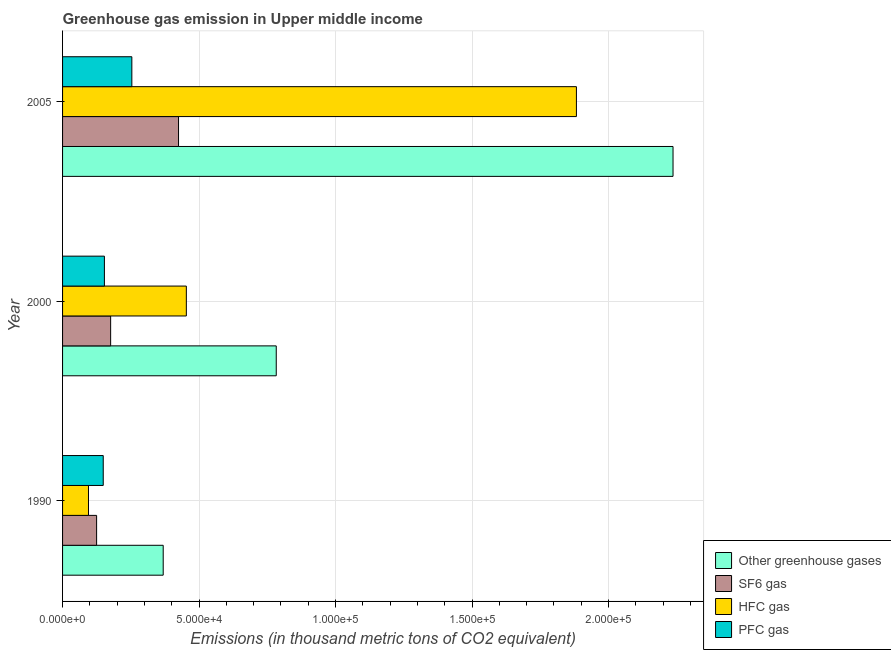How many groups of bars are there?
Provide a succinct answer. 3. Are the number of bars on each tick of the Y-axis equal?
Offer a terse response. Yes. In how many cases, is the number of bars for a given year not equal to the number of legend labels?
Keep it short and to the point. 0. What is the emission of pfc gas in 1990?
Keep it short and to the point. 1.49e+04. Across all years, what is the maximum emission of hfc gas?
Your answer should be compact. 1.88e+05. Across all years, what is the minimum emission of greenhouse gases?
Offer a very short reply. 3.69e+04. In which year was the emission of sf6 gas maximum?
Provide a succinct answer. 2005. In which year was the emission of sf6 gas minimum?
Keep it short and to the point. 1990. What is the total emission of hfc gas in the graph?
Ensure brevity in your answer.  2.43e+05. What is the difference between the emission of hfc gas in 2000 and that in 2005?
Offer a terse response. -1.43e+05. What is the difference between the emission of greenhouse gases in 1990 and the emission of pfc gas in 2005?
Your answer should be compact. 1.15e+04. What is the average emission of greenhouse gases per year?
Give a very brief answer. 1.13e+05. In the year 2000, what is the difference between the emission of pfc gas and emission of sf6 gas?
Give a very brief answer. -2284.5. In how many years, is the emission of hfc gas greater than 140000 thousand metric tons?
Ensure brevity in your answer.  1. What is the ratio of the emission of sf6 gas in 1990 to that in 2005?
Ensure brevity in your answer.  0.29. Is the emission of pfc gas in 1990 less than that in 2000?
Offer a very short reply. Yes. Is the difference between the emission of sf6 gas in 1990 and 2005 greater than the difference between the emission of greenhouse gases in 1990 and 2005?
Offer a terse response. Yes. What is the difference between the highest and the second highest emission of greenhouse gases?
Your response must be concise. 1.45e+05. What is the difference between the highest and the lowest emission of hfc gas?
Make the answer very short. 1.79e+05. Is the sum of the emission of pfc gas in 1990 and 2000 greater than the maximum emission of hfc gas across all years?
Offer a very short reply. No. What does the 4th bar from the top in 2005 represents?
Make the answer very short. Other greenhouse gases. What does the 2nd bar from the bottom in 1990 represents?
Your response must be concise. SF6 gas. Is it the case that in every year, the sum of the emission of greenhouse gases and emission of sf6 gas is greater than the emission of hfc gas?
Provide a short and direct response. Yes. Are all the bars in the graph horizontal?
Ensure brevity in your answer.  Yes. How many years are there in the graph?
Your response must be concise. 3. Are the values on the major ticks of X-axis written in scientific E-notation?
Your answer should be compact. Yes. Does the graph contain grids?
Your answer should be very brief. Yes. How many legend labels are there?
Give a very brief answer. 4. How are the legend labels stacked?
Ensure brevity in your answer.  Vertical. What is the title of the graph?
Your answer should be compact. Greenhouse gas emission in Upper middle income. Does "Argument" appear as one of the legend labels in the graph?
Provide a short and direct response. No. What is the label or title of the X-axis?
Keep it short and to the point. Emissions (in thousand metric tons of CO2 equivalent). What is the Emissions (in thousand metric tons of CO2 equivalent) in Other greenhouse gases in 1990?
Make the answer very short. 3.69e+04. What is the Emissions (in thousand metric tons of CO2 equivalent) in SF6 gas in 1990?
Your response must be concise. 1.25e+04. What is the Emissions (in thousand metric tons of CO2 equivalent) in HFC gas in 1990?
Your answer should be compact. 9496.9. What is the Emissions (in thousand metric tons of CO2 equivalent) of PFC gas in 1990?
Make the answer very short. 1.49e+04. What is the Emissions (in thousand metric tons of CO2 equivalent) in Other greenhouse gases in 2000?
Provide a short and direct response. 7.83e+04. What is the Emissions (in thousand metric tons of CO2 equivalent) in SF6 gas in 2000?
Your answer should be compact. 1.76e+04. What is the Emissions (in thousand metric tons of CO2 equivalent) in HFC gas in 2000?
Keep it short and to the point. 4.53e+04. What is the Emissions (in thousand metric tons of CO2 equivalent) of PFC gas in 2000?
Your answer should be very brief. 1.53e+04. What is the Emissions (in thousand metric tons of CO2 equivalent) in Other greenhouse gases in 2005?
Keep it short and to the point. 2.24e+05. What is the Emissions (in thousand metric tons of CO2 equivalent) in SF6 gas in 2005?
Make the answer very short. 4.25e+04. What is the Emissions (in thousand metric tons of CO2 equivalent) of HFC gas in 2005?
Give a very brief answer. 1.88e+05. What is the Emissions (in thousand metric tons of CO2 equivalent) in PFC gas in 2005?
Give a very brief answer. 2.54e+04. Across all years, what is the maximum Emissions (in thousand metric tons of CO2 equivalent) in Other greenhouse gases?
Provide a short and direct response. 2.24e+05. Across all years, what is the maximum Emissions (in thousand metric tons of CO2 equivalent) in SF6 gas?
Give a very brief answer. 4.25e+04. Across all years, what is the maximum Emissions (in thousand metric tons of CO2 equivalent) of HFC gas?
Give a very brief answer. 1.88e+05. Across all years, what is the maximum Emissions (in thousand metric tons of CO2 equivalent) of PFC gas?
Ensure brevity in your answer.  2.54e+04. Across all years, what is the minimum Emissions (in thousand metric tons of CO2 equivalent) of Other greenhouse gases?
Ensure brevity in your answer.  3.69e+04. Across all years, what is the minimum Emissions (in thousand metric tons of CO2 equivalent) in SF6 gas?
Keep it short and to the point. 1.25e+04. Across all years, what is the minimum Emissions (in thousand metric tons of CO2 equivalent) in HFC gas?
Offer a very short reply. 9496.9. Across all years, what is the minimum Emissions (in thousand metric tons of CO2 equivalent) in PFC gas?
Provide a short and direct response. 1.49e+04. What is the total Emissions (in thousand metric tons of CO2 equivalent) in Other greenhouse gases in the graph?
Provide a short and direct response. 3.39e+05. What is the total Emissions (in thousand metric tons of CO2 equivalent) of SF6 gas in the graph?
Provide a short and direct response. 7.26e+04. What is the total Emissions (in thousand metric tons of CO2 equivalent) of HFC gas in the graph?
Give a very brief answer. 2.43e+05. What is the total Emissions (in thousand metric tons of CO2 equivalent) in PFC gas in the graph?
Offer a very short reply. 5.56e+04. What is the difference between the Emissions (in thousand metric tons of CO2 equivalent) in Other greenhouse gases in 1990 and that in 2000?
Your answer should be very brief. -4.14e+04. What is the difference between the Emissions (in thousand metric tons of CO2 equivalent) in SF6 gas in 1990 and that in 2000?
Ensure brevity in your answer.  -5140.8. What is the difference between the Emissions (in thousand metric tons of CO2 equivalent) of HFC gas in 1990 and that in 2000?
Keep it short and to the point. -3.58e+04. What is the difference between the Emissions (in thousand metric tons of CO2 equivalent) in PFC gas in 1990 and that in 2000?
Offer a very short reply. -426.2. What is the difference between the Emissions (in thousand metric tons of CO2 equivalent) of Other greenhouse gases in 1990 and that in 2005?
Give a very brief answer. -1.87e+05. What is the difference between the Emissions (in thousand metric tons of CO2 equivalent) in SF6 gas in 1990 and that in 2005?
Make the answer very short. -3.00e+04. What is the difference between the Emissions (in thousand metric tons of CO2 equivalent) of HFC gas in 1990 and that in 2005?
Provide a succinct answer. -1.79e+05. What is the difference between the Emissions (in thousand metric tons of CO2 equivalent) in PFC gas in 1990 and that in 2005?
Provide a short and direct response. -1.05e+04. What is the difference between the Emissions (in thousand metric tons of CO2 equivalent) of Other greenhouse gases in 2000 and that in 2005?
Offer a very short reply. -1.45e+05. What is the difference between the Emissions (in thousand metric tons of CO2 equivalent) in SF6 gas in 2000 and that in 2005?
Provide a succinct answer. -2.49e+04. What is the difference between the Emissions (in thousand metric tons of CO2 equivalent) of HFC gas in 2000 and that in 2005?
Your answer should be very brief. -1.43e+05. What is the difference between the Emissions (in thousand metric tons of CO2 equivalent) of PFC gas in 2000 and that in 2005?
Provide a succinct answer. -1.01e+04. What is the difference between the Emissions (in thousand metric tons of CO2 equivalent) in Other greenhouse gases in 1990 and the Emissions (in thousand metric tons of CO2 equivalent) in SF6 gas in 2000?
Make the answer very short. 1.93e+04. What is the difference between the Emissions (in thousand metric tons of CO2 equivalent) of Other greenhouse gases in 1990 and the Emissions (in thousand metric tons of CO2 equivalent) of HFC gas in 2000?
Provide a succinct answer. -8475.4. What is the difference between the Emissions (in thousand metric tons of CO2 equivalent) of Other greenhouse gases in 1990 and the Emissions (in thousand metric tons of CO2 equivalent) of PFC gas in 2000?
Offer a very short reply. 2.15e+04. What is the difference between the Emissions (in thousand metric tons of CO2 equivalent) of SF6 gas in 1990 and the Emissions (in thousand metric tons of CO2 equivalent) of HFC gas in 2000?
Make the answer very short. -3.29e+04. What is the difference between the Emissions (in thousand metric tons of CO2 equivalent) of SF6 gas in 1990 and the Emissions (in thousand metric tons of CO2 equivalent) of PFC gas in 2000?
Make the answer very short. -2856.3. What is the difference between the Emissions (in thousand metric tons of CO2 equivalent) in HFC gas in 1990 and the Emissions (in thousand metric tons of CO2 equivalent) in PFC gas in 2000?
Provide a short and direct response. -5829.9. What is the difference between the Emissions (in thousand metric tons of CO2 equivalent) of Other greenhouse gases in 1990 and the Emissions (in thousand metric tons of CO2 equivalent) of SF6 gas in 2005?
Make the answer very short. -5611.03. What is the difference between the Emissions (in thousand metric tons of CO2 equivalent) in Other greenhouse gases in 1990 and the Emissions (in thousand metric tons of CO2 equivalent) in HFC gas in 2005?
Make the answer very short. -1.51e+05. What is the difference between the Emissions (in thousand metric tons of CO2 equivalent) of Other greenhouse gases in 1990 and the Emissions (in thousand metric tons of CO2 equivalent) of PFC gas in 2005?
Provide a succinct answer. 1.15e+04. What is the difference between the Emissions (in thousand metric tons of CO2 equivalent) of SF6 gas in 1990 and the Emissions (in thousand metric tons of CO2 equivalent) of HFC gas in 2005?
Your response must be concise. -1.76e+05. What is the difference between the Emissions (in thousand metric tons of CO2 equivalent) in SF6 gas in 1990 and the Emissions (in thousand metric tons of CO2 equivalent) in PFC gas in 2005?
Offer a terse response. -1.29e+04. What is the difference between the Emissions (in thousand metric tons of CO2 equivalent) in HFC gas in 1990 and the Emissions (in thousand metric tons of CO2 equivalent) in PFC gas in 2005?
Offer a terse response. -1.59e+04. What is the difference between the Emissions (in thousand metric tons of CO2 equivalent) of Other greenhouse gases in 2000 and the Emissions (in thousand metric tons of CO2 equivalent) of SF6 gas in 2005?
Your response must be concise. 3.58e+04. What is the difference between the Emissions (in thousand metric tons of CO2 equivalent) of Other greenhouse gases in 2000 and the Emissions (in thousand metric tons of CO2 equivalent) of HFC gas in 2005?
Your answer should be very brief. -1.10e+05. What is the difference between the Emissions (in thousand metric tons of CO2 equivalent) of Other greenhouse gases in 2000 and the Emissions (in thousand metric tons of CO2 equivalent) of PFC gas in 2005?
Your response must be concise. 5.29e+04. What is the difference between the Emissions (in thousand metric tons of CO2 equivalent) of SF6 gas in 2000 and the Emissions (in thousand metric tons of CO2 equivalent) of HFC gas in 2005?
Provide a short and direct response. -1.71e+05. What is the difference between the Emissions (in thousand metric tons of CO2 equivalent) of SF6 gas in 2000 and the Emissions (in thousand metric tons of CO2 equivalent) of PFC gas in 2005?
Provide a succinct answer. -7766.13. What is the difference between the Emissions (in thousand metric tons of CO2 equivalent) of HFC gas in 2000 and the Emissions (in thousand metric tons of CO2 equivalent) of PFC gas in 2005?
Offer a very short reply. 2.00e+04. What is the average Emissions (in thousand metric tons of CO2 equivalent) of Other greenhouse gases per year?
Offer a very short reply. 1.13e+05. What is the average Emissions (in thousand metric tons of CO2 equivalent) of SF6 gas per year?
Ensure brevity in your answer.  2.42e+04. What is the average Emissions (in thousand metric tons of CO2 equivalent) in HFC gas per year?
Provide a succinct answer. 8.10e+04. What is the average Emissions (in thousand metric tons of CO2 equivalent) in PFC gas per year?
Ensure brevity in your answer.  1.85e+04. In the year 1990, what is the difference between the Emissions (in thousand metric tons of CO2 equivalent) of Other greenhouse gases and Emissions (in thousand metric tons of CO2 equivalent) of SF6 gas?
Offer a very short reply. 2.44e+04. In the year 1990, what is the difference between the Emissions (in thousand metric tons of CO2 equivalent) in Other greenhouse gases and Emissions (in thousand metric tons of CO2 equivalent) in HFC gas?
Offer a terse response. 2.74e+04. In the year 1990, what is the difference between the Emissions (in thousand metric tons of CO2 equivalent) of Other greenhouse gases and Emissions (in thousand metric tons of CO2 equivalent) of PFC gas?
Offer a very short reply. 2.20e+04. In the year 1990, what is the difference between the Emissions (in thousand metric tons of CO2 equivalent) in SF6 gas and Emissions (in thousand metric tons of CO2 equivalent) in HFC gas?
Provide a succinct answer. 2973.6. In the year 1990, what is the difference between the Emissions (in thousand metric tons of CO2 equivalent) in SF6 gas and Emissions (in thousand metric tons of CO2 equivalent) in PFC gas?
Your response must be concise. -2430.1. In the year 1990, what is the difference between the Emissions (in thousand metric tons of CO2 equivalent) of HFC gas and Emissions (in thousand metric tons of CO2 equivalent) of PFC gas?
Make the answer very short. -5403.7. In the year 2000, what is the difference between the Emissions (in thousand metric tons of CO2 equivalent) in Other greenhouse gases and Emissions (in thousand metric tons of CO2 equivalent) in SF6 gas?
Ensure brevity in your answer.  6.07e+04. In the year 2000, what is the difference between the Emissions (in thousand metric tons of CO2 equivalent) of Other greenhouse gases and Emissions (in thousand metric tons of CO2 equivalent) of HFC gas?
Give a very brief answer. 3.29e+04. In the year 2000, what is the difference between the Emissions (in thousand metric tons of CO2 equivalent) of Other greenhouse gases and Emissions (in thousand metric tons of CO2 equivalent) of PFC gas?
Give a very brief answer. 6.30e+04. In the year 2000, what is the difference between the Emissions (in thousand metric tons of CO2 equivalent) in SF6 gas and Emissions (in thousand metric tons of CO2 equivalent) in HFC gas?
Keep it short and to the point. -2.77e+04. In the year 2000, what is the difference between the Emissions (in thousand metric tons of CO2 equivalent) in SF6 gas and Emissions (in thousand metric tons of CO2 equivalent) in PFC gas?
Offer a very short reply. 2284.5. In the year 2000, what is the difference between the Emissions (in thousand metric tons of CO2 equivalent) in HFC gas and Emissions (in thousand metric tons of CO2 equivalent) in PFC gas?
Give a very brief answer. 3.00e+04. In the year 2005, what is the difference between the Emissions (in thousand metric tons of CO2 equivalent) of Other greenhouse gases and Emissions (in thousand metric tons of CO2 equivalent) of SF6 gas?
Offer a terse response. 1.81e+05. In the year 2005, what is the difference between the Emissions (in thousand metric tons of CO2 equivalent) in Other greenhouse gases and Emissions (in thousand metric tons of CO2 equivalent) in HFC gas?
Make the answer very short. 3.54e+04. In the year 2005, what is the difference between the Emissions (in thousand metric tons of CO2 equivalent) in Other greenhouse gases and Emissions (in thousand metric tons of CO2 equivalent) in PFC gas?
Your response must be concise. 1.98e+05. In the year 2005, what is the difference between the Emissions (in thousand metric tons of CO2 equivalent) in SF6 gas and Emissions (in thousand metric tons of CO2 equivalent) in HFC gas?
Provide a short and direct response. -1.46e+05. In the year 2005, what is the difference between the Emissions (in thousand metric tons of CO2 equivalent) of SF6 gas and Emissions (in thousand metric tons of CO2 equivalent) of PFC gas?
Your answer should be very brief. 1.71e+04. In the year 2005, what is the difference between the Emissions (in thousand metric tons of CO2 equivalent) in HFC gas and Emissions (in thousand metric tons of CO2 equivalent) in PFC gas?
Your answer should be very brief. 1.63e+05. What is the ratio of the Emissions (in thousand metric tons of CO2 equivalent) in Other greenhouse gases in 1990 to that in 2000?
Your response must be concise. 0.47. What is the ratio of the Emissions (in thousand metric tons of CO2 equivalent) of SF6 gas in 1990 to that in 2000?
Provide a short and direct response. 0.71. What is the ratio of the Emissions (in thousand metric tons of CO2 equivalent) in HFC gas in 1990 to that in 2000?
Make the answer very short. 0.21. What is the ratio of the Emissions (in thousand metric tons of CO2 equivalent) of PFC gas in 1990 to that in 2000?
Make the answer very short. 0.97. What is the ratio of the Emissions (in thousand metric tons of CO2 equivalent) in Other greenhouse gases in 1990 to that in 2005?
Provide a succinct answer. 0.16. What is the ratio of the Emissions (in thousand metric tons of CO2 equivalent) in SF6 gas in 1990 to that in 2005?
Your response must be concise. 0.29. What is the ratio of the Emissions (in thousand metric tons of CO2 equivalent) of HFC gas in 1990 to that in 2005?
Keep it short and to the point. 0.05. What is the ratio of the Emissions (in thousand metric tons of CO2 equivalent) in PFC gas in 1990 to that in 2005?
Make the answer very short. 0.59. What is the ratio of the Emissions (in thousand metric tons of CO2 equivalent) in SF6 gas in 2000 to that in 2005?
Ensure brevity in your answer.  0.41. What is the ratio of the Emissions (in thousand metric tons of CO2 equivalent) in HFC gas in 2000 to that in 2005?
Offer a terse response. 0.24. What is the ratio of the Emissions (in thousand metric tons of CO2 equivalent) in PFC gas in 2000 to that in 2005?
Your answer should be very brief. 0.6. What is the difference between the highest and the second highest Emissions (in thousand metric tons of CO2 equivalent) of Other greenhouse gases?
Provide a short and direct response. 1.45e+05. What is the difference between the highest and the second highest Emissions (in thousand metric tons of CO2 equivalent) of SF6 gas?
Give a very brief answer. 2.49e+04. What is the difference between the highest and the second highest Emissions (in thousand metric tons of CO2 equivalent) in HFC gas?
Offer a very short reply. 1.43e+05. What is the difference between the highest and the second highest Emissions (in thousand metric tons of CO2 equivalent) in PFC gas?
Provide a succinct answer. 1.01e+04. What is the difference between the highest and the lowest Emissions (in thousand metric tons of CO2 equivalent) of Other greenhouse gases?
Your response must be concise. 1.87e+05. What is the difference between the highest and the lowest Emissions (in thousand metric tons of CO2 equivalent) in SF6 gas?
Offer a terse response. 3.00e+04. What is the difference between the highest and the lowest Emissions (in thousand metric tons of CO2 equivalent) of HFC gas?
Your answer should be compact. 1.79e+05. What is the difference between the highest and the lowest Emissions (in thousand metric tons of CO2 equivalent) in PFC gas?
Make the answer very short. 1.05e+04. 